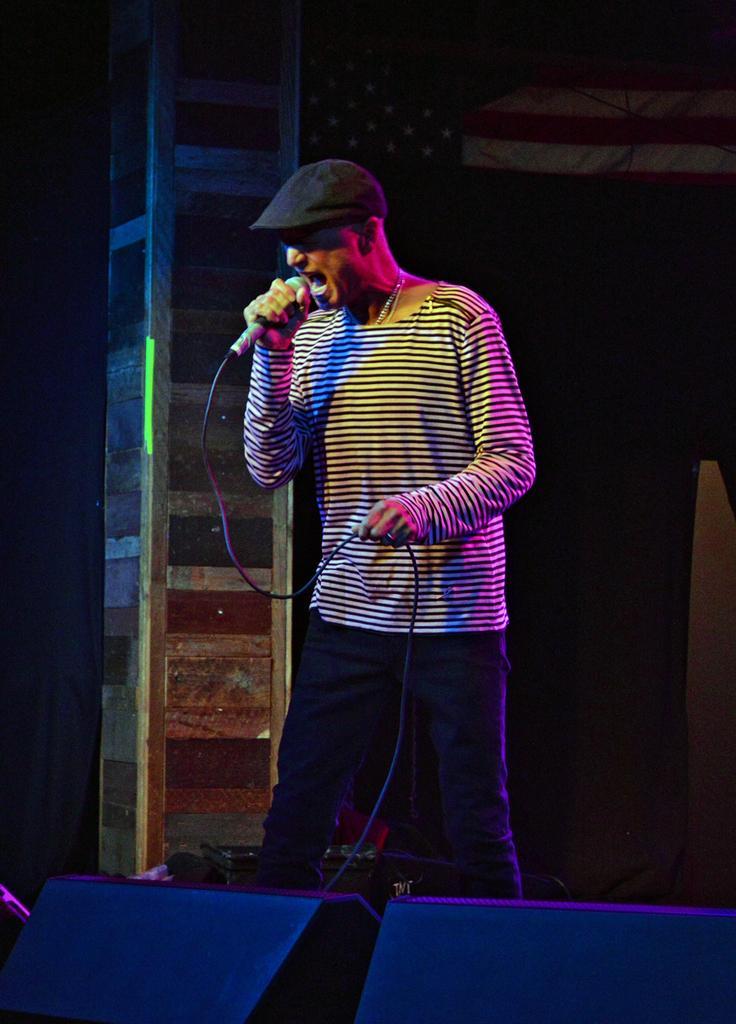Please provide a concise description of this image. In the image we can see there is a man standing and he is holding mic in his hand. There are speakers kept on the stage. 